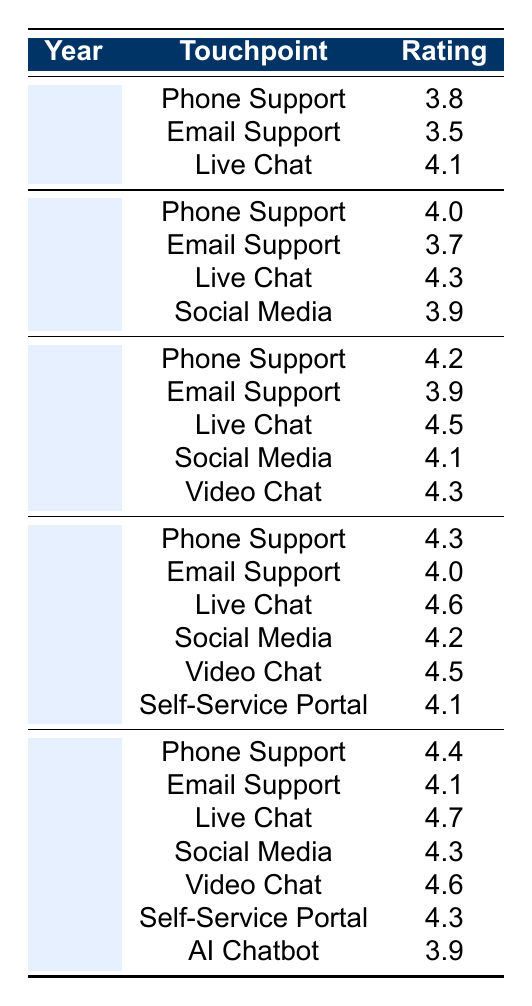What was the rating for Live Chat in 2020? In the table, under the year 2020 for the touchpoint Live Chat, the rating is listed as 4.5.
Answer: 4.5 Which year had the highest rating for Email Support? By comparing the ratings for Email Support across all years, the highest rating is 4.1, which occurred in 2022.
Answer: 2022 What are the ratings for Phone Support across all years? The ratings for Phone Support are as follows: 3.8 (2018), 4.0 (2019), 4.2 (2020), 4.3 (2021), and 4.4 (2022).
Answer: 3.8, 4.0, 4.2, 4.3, 4.4 Was there any year when the rating for Social Media was below 4.0? The year 2018 shows a rating of 3.9 for Social Media, which is below 4.0.
Answer: Yes What was the average rating for Live Chat from 2018 to 2022? The ratings for Live Chat from 2018 to 2022 are 4.1 (2018), 4.3 (2019), 4.5 (2020), 4.6 (2021), and 4.7 (2022). Their sum is 4.1 + 4.3 + 4.5 + 4.6 + 4.7 = 22.2. The average is 22.2 divided by 5, which equals 4.44.
Answer: 4.44 Which touchpoint had the lowest rating in 2019? In 2019, Email Support received the lowest rating of 3.7 compared to the ratings of the other touchpoints.
Answer: 3.7 How did the rating for Video Chat change from 2020 to 2021? In 2020, Video Chat received a rating of 4.3, and in 2021, it was rated at 4.5. The change is an increase of 0.2.
Answer: It increased by 0.2 In which year did AI Chatbot receive its rating? The rating for AI Chatbot is present only in the year 2022, where it received a rating of 3.9.
Answer: 2022 Was the average rating for Phone Support above 4.0 in 2021? The rating for Phone Support in 2021 is 4.3, which is indeed above 4.0.
Answer: Yes What is the difference in the rating for Self-Service Portal between 2021 and 2022? The rating for Self-Service Portal in 2021 is 4.1, and in 2022 it is 4.3. The difference is 4.3 - 4.1 = 0.2.
Answer: 0.2 Which touchpoint consistently had a rating above 4.0 from 2019 to 2022? Reviewing the ratings from 2019 to 2022, Live Chat consistently had ratings above 4.0: 4.3 (2019), 4.5 (2020), 4.6 (2021), and 4.7 (2022).
Answer: Live Chat 